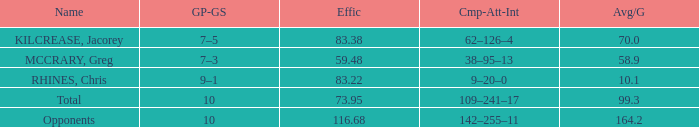What is the lowest effic with a 58.9 avg/g? 59.48. 